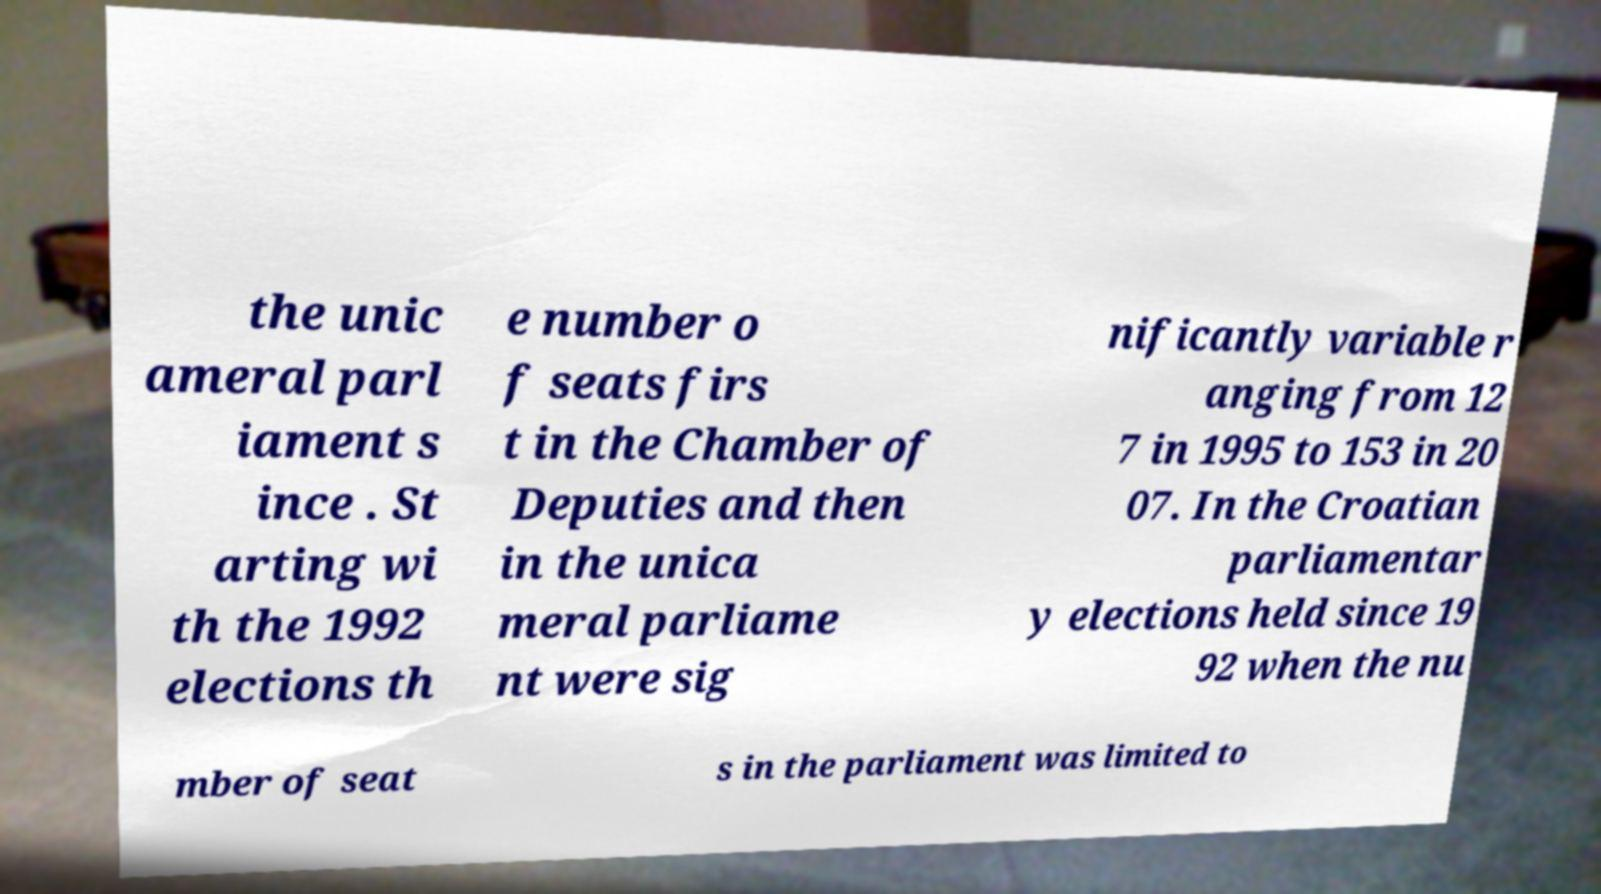Can you accurately transcribe the text from the provided image for me? the unic ameral parl iament s ince . St arting wi th the 1992 elections th e number o f seats firs t in the Chamber of Deputies and then in the unica meral parliame nt were sig nificantly variable r anging from 12 7 in 1995 to 153 in 20 07. In the Croatian parliamentar y elections held since 19 92 when the nu mber of seat s in the parliament was limited to 